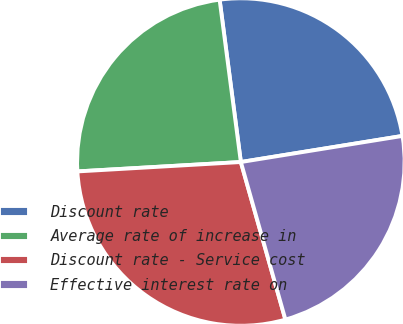<chart> <loc_0><loc_0><loc_500><loc_500><pie_chart><fcel>Discount rate<fcel>Average rate of increase in<fcel>Discount rate - Service cost<fcel>Effective interest rate on<nl><fcel>24.52%<fcel>23.84%<fcel>28.47%<fcel>23.16%<nl></chart> 